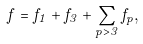Convert formula to latex. <formula><loc_0><loc_0><loc_500><loc_500>f = f _ { 1 } + f _ { 3 } + \sum _ { p > 3 } f _ { p } ,</formula> 